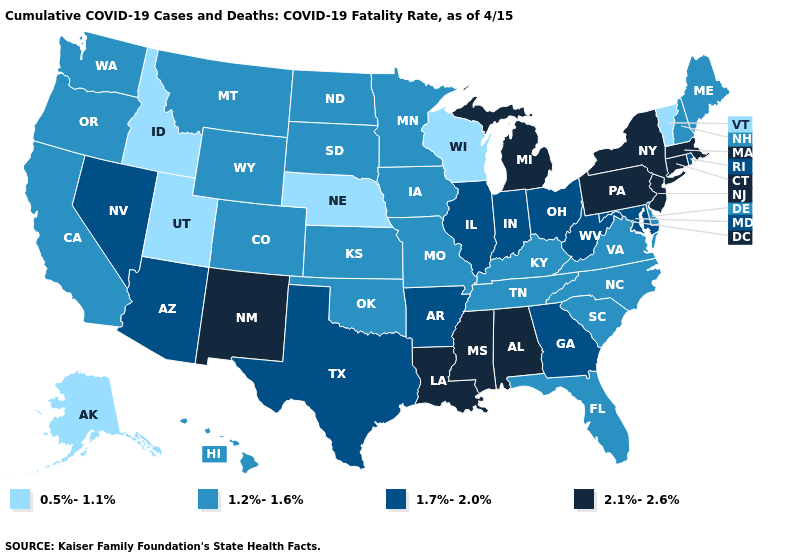What is the highest value in states that border New Jersey?
Write a very short answer. 2.1%-2.6%. Does Alaska have the lowest value in the USA?
Short answer required. Yes. What is the value of Minnesota?
Keep it brief. 1.2%-1.6%. Which states have the lowest value in the West?
Answer briefly. Alaska, Idaho, Utah. What is the value of Georgia?
Write a very short answer. 1.7%-2.0%. Does Vermont have the lowest value in the Northeast?
Be succinct. Yes. Name the states that have a value in the range 1.2%-1.6%?
Short answer required. California, Colorado, Delaware, Florida, Hawaii, Iowa, Kansas, Kentucky, Maine, Minnesota, Missouri, Montana, New Hampshire, North Carolina, North Dakota, Oklahoma, Oregon, South Carolina, South Dakota, Tennessee, Virginia, Washington, Wyoming. Among the states that border Florida , does Alabama have the highest value?
Keep it brief. Yes. Among the states that border Mississippi , which have the lowest value?
Keep it brief. Tennessee. What is the value of Virginia?
Answer briefly. 1.2%-1.6%. Does Alabama have the highest value in the USA?
Write a very short answer. Yes. Is the legend a continuous bar?
Give a very brief answer. No. Name the states that have a value in the range 1.2%-1.6%?
Write a very short answer. California, Colorado, Delaware, Florida, Hawaii, Iowa, Kansas, Kentucky, Maine, Minnesota, Missouri, Montana, New Hampshire, North Carolina, North Dakota, Oklahoma, Oregon, South Carolina, South Dakota, Tennessee, Virginia, Washington, Wyoming. Does California have a lower value than Indiana?
Quick response, please. Yes. Does the map have missing data?
Short answer required. No. 